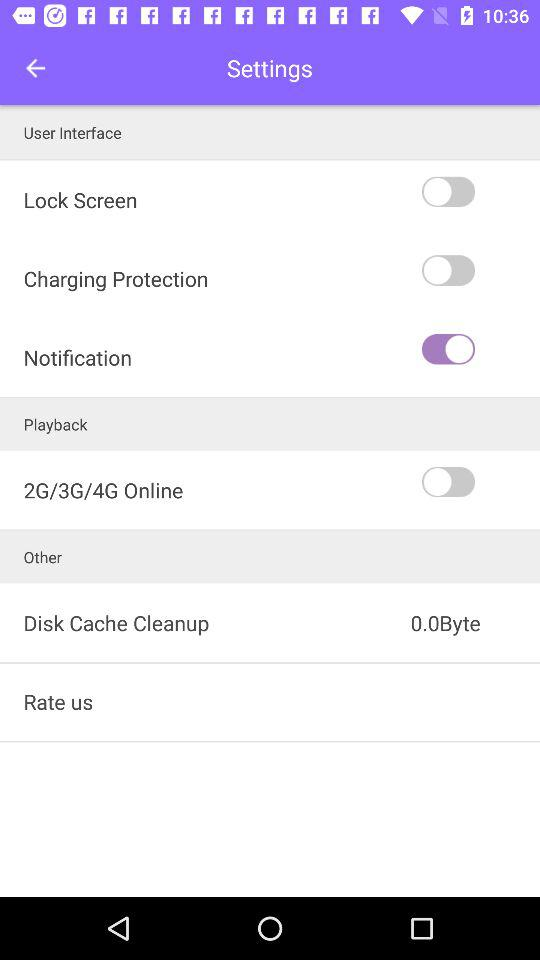How many switches are there in the User Interface section?
Answer the question using a single word or phrase. 3 